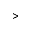<formula> <loc_0><loc_0><loc_500><loc_500>></formula> 